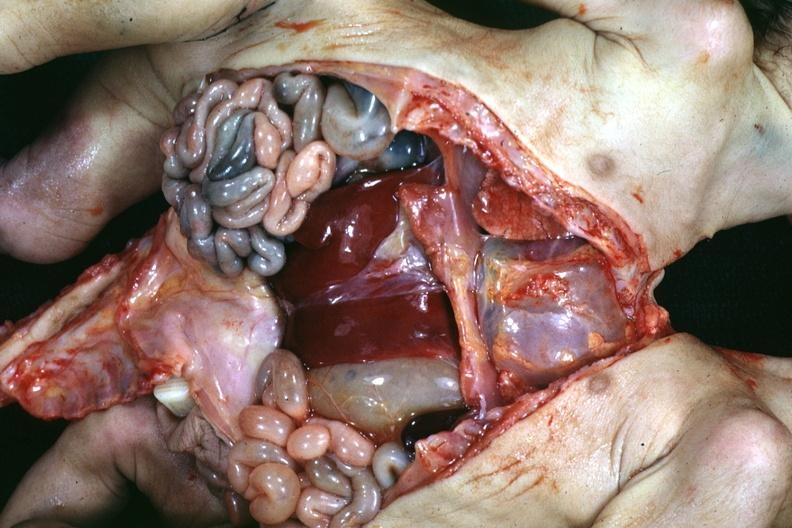how many sets does this image show joined lower chest and abdomen anterior opened lower chest and abdomen showing apparent intestine with one liver?
Answer the question using a single word or phrase. Two 